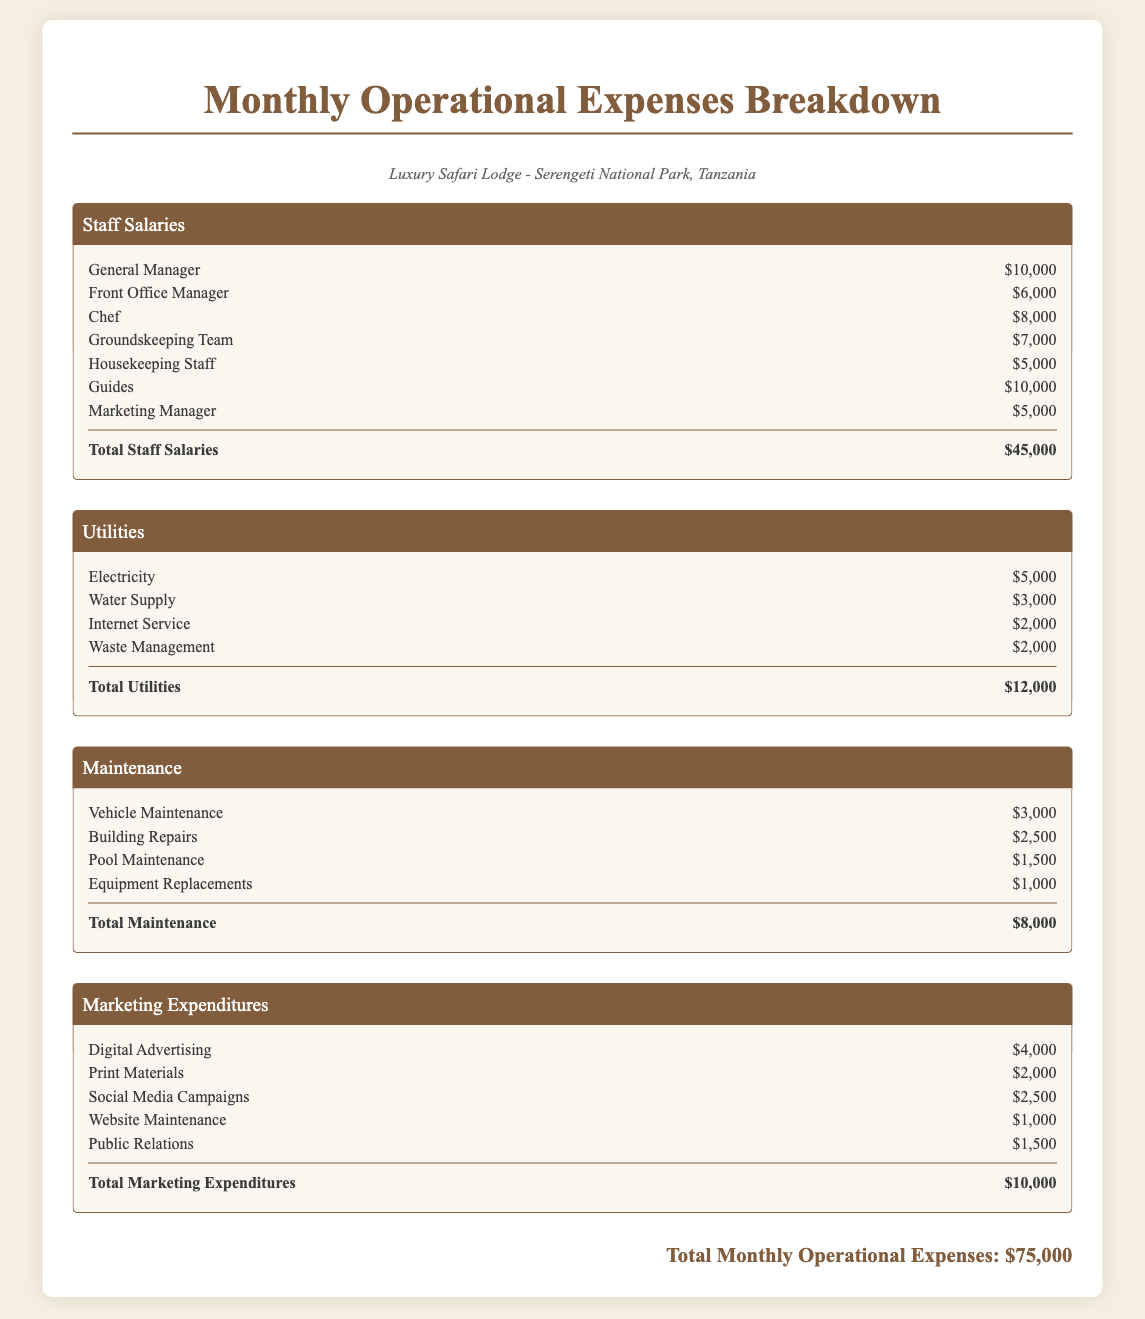What is the total amount allocated for staff salaries? The total staff salaries are listed as a separate section where all individual salaries are summed up to $45,000.
Answer: $45,000 What is the monthly expenditure for electricity? The document specifies that the electricity cost is listed under the utilities section as $5,000.
Answer: $5,000 How much is spent on digital advertising? The marketing expenditures section includes a line for digital advertising, which states the amount is $4,000.
Answer: $4,000 What is the total cost for maintenance? The maintenance section summarizes costs that add up to $8,000, which is provided as the total at the end of that section.
Answer: $8,000 Who is the highest paid staff member? The highest paid staff member is the General Manager with a salary of $10,000 mentioned in the staff salaries section.
Answer: General Manager What are the total monthly operational expenses? The grand total is calculated and clearly stated at the bottom of the document as the total operational expenses for the month.
Answer: $75,000 What is the cost for pool maintenance? Pool maintenance is explicitly listed in the maintenance section with a specific cost of $1,500.
Answer: $1,500 How much is allocated for public relations? In the marketing expenditures, the public relations cost is directly specified as $1,500.
Answer: $1,500 What is the expenditure for the Groundskeeping Team? The Groundskeeping Team's salary is noted in the staff salaries section, indicating it costs $7,000 per month.
Answer: $7,000 